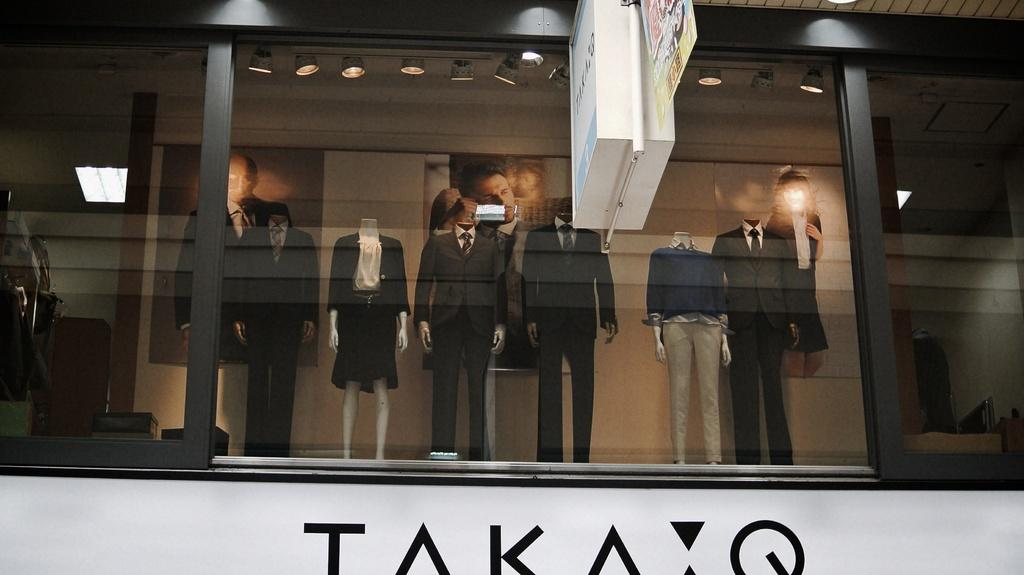What type of structure is visible in the image? There is a building in the image. What kind of business might be operating in the building? The building appears to be a clothes shop. What can be found inside the building? There are mannequins in the building. What type of wine is being served in the clothes shop? There is no mention of wine or any serving activity in the image. The image features a building that appears to be a clothes shop with mannequins inside. 